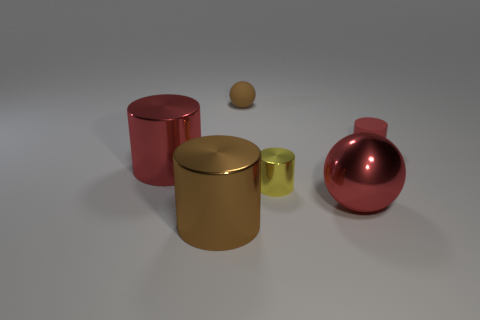What does the arrangement of these objects suggest? The arrangement could imply a study of geometric shapes and colors in a minimalistic setting. Each object has been placed with some space in between, allowing individual assessment while also creating a collective visual balance. It can suggest a comparison or contrast, as well as a sense of order, as if the objects are curated for display or scrutiny. Is there anything unique about the lighting or shadows? Yes, there is. The lighting is coming from above, casting diffuse, soft shadows to the right of each object, which adds dimension and depth to the scene. The softness of the shadows indicates that the light source is not very close, creating an evenly lit setting that is typical for presenting objects in a neutral manner, free from dramatic contrasts or harsh highlights. 